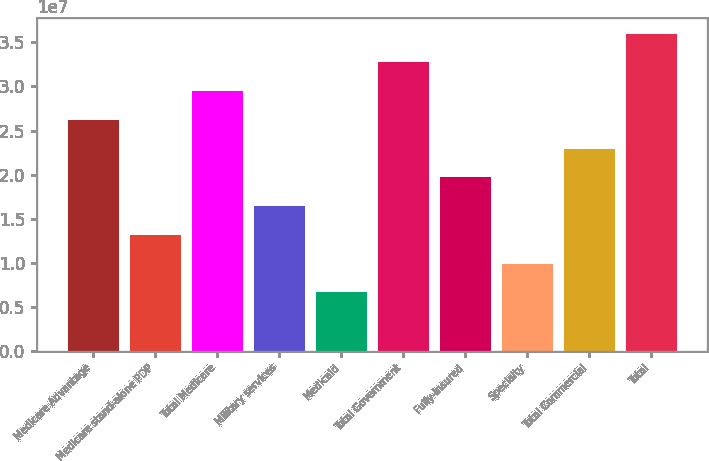<chart> <loc_0><loc_0><loc_500><loc_500><bar_chart><fcel>Medicare Advantage<fcel>Medicare stand-alone PDP<fcel>Total Medicare<fcel>Military services<fcel>Medicaid<fcel>Total Government<fcel>Fully-insured<fcel>Specialty<fcel>Total Commercial<fcel>Total<nl><fcel>2.61929e+07<fcel>1.3154e+07<fcel>2.94526e+07<fcel>1.64138e+07<fcel>6.63462e+06<fcel>3.27123e+07<fcel>1.96735e+07<fcel>9.89433e+06<fcel>2.29332e+07<fcel>3.5972e+07<nl></chart> 